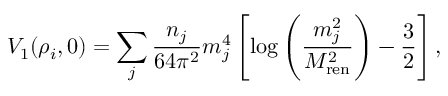<formula> <loc_0><loc_0><loc_500><loc_500>V _ { 1 } ( \rho _ { i } , 0 ) = \sum _ { j } { \frac { n _ { j } } { 6 4 \pi ^ { 2 } } } m _ { j } ^ { 4 } \left [ \log \left ( { \frac { m _ { j } ^ { 2 } } { M _ { r e n } ^ { 2 } } } \right ) - { \frac { 3 } { 2 } } \right ] ,</formula> 